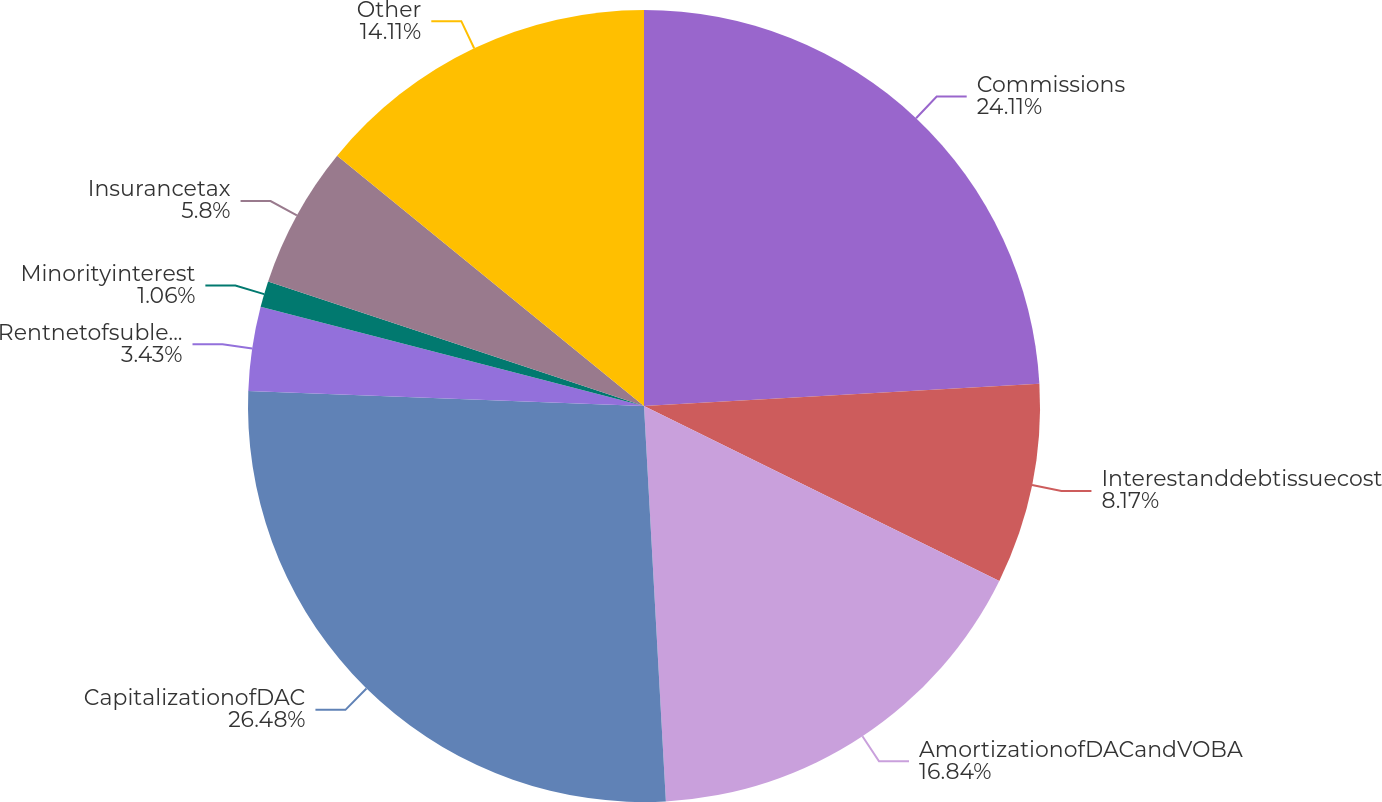Convert chart. <chart><loc_0><loc_0><loc_500><loc_500><pie_chart><fcel>Commissions<fcel>Interestanddebtissuecost<fcel>AmortizationofDACandVOBA<fcel>CapitalizationofDAC<fcel>Rentnetofsubleaseincome<fcel>Minorityinterest<fcel>Insurancetax<fcel>Other<nl><fcel>24.11%<fcel>8.17%<fcel>16.84%<fcel>26.48%<fcel>3.43%<fcel>1.06%<fcel>5.8%<fcel>14.11%<nl></chart> 